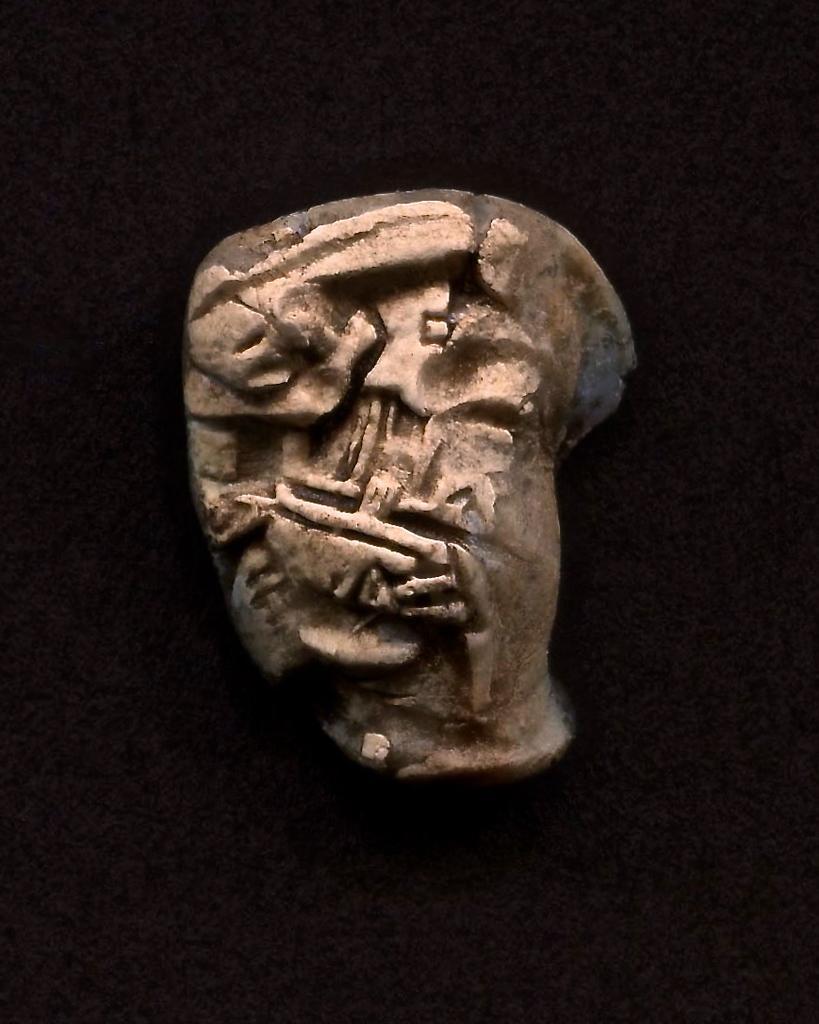Can you describe this image briefly? In this image I can see the rock and I can see the dark background. 